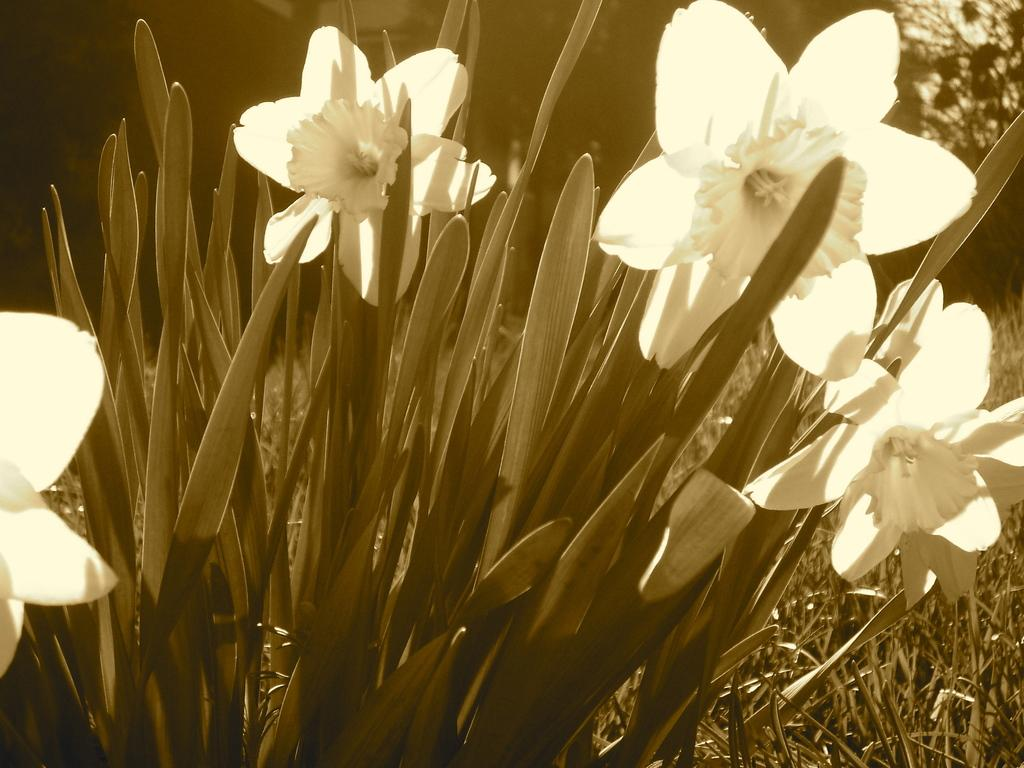What type of plant is visible in the image? There is a plant with flowers in the image. Can you describe the background of the image? There is a tree visible in the background of the image, specifically on the right side. How many dogs are playing with the rifle in the image? There are no dogs or rifles present in the image. What religious symbols can be seen in the image? There are no religious symbols present in the image. 